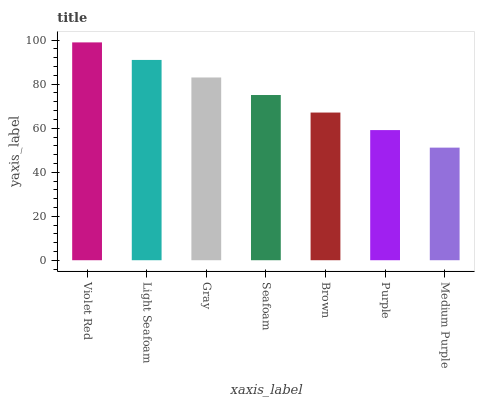Is Medium Purple the minimum?
Answer yes or no. Yes. Is Violet Red the maximum?
Answer yes or no. Yes. Is Light Seafoam the minimum?
Answer yes or no. No. Is Light Seafoam the maximum?
Answer yes or no. No. Is Violet Red greater than Light Seafoam?
Answer yes or no. Yes. Is Light Seafoam less than Violet Red?
Answer yes or no. Yes. Is Light Seafoam greater than Violet Red?
Answer yes or no. No. Is Violet Red less than Light Seafoam?
Answer yes or no. No. Is Seafoam the high median?
Answer yes or no. Yes. Is Seafoam the low median?
Answer yes or no. Yes. Is Purple the high median?
Answer yes or no. No. Is Gray the low median?
Answer yes or no. No. 